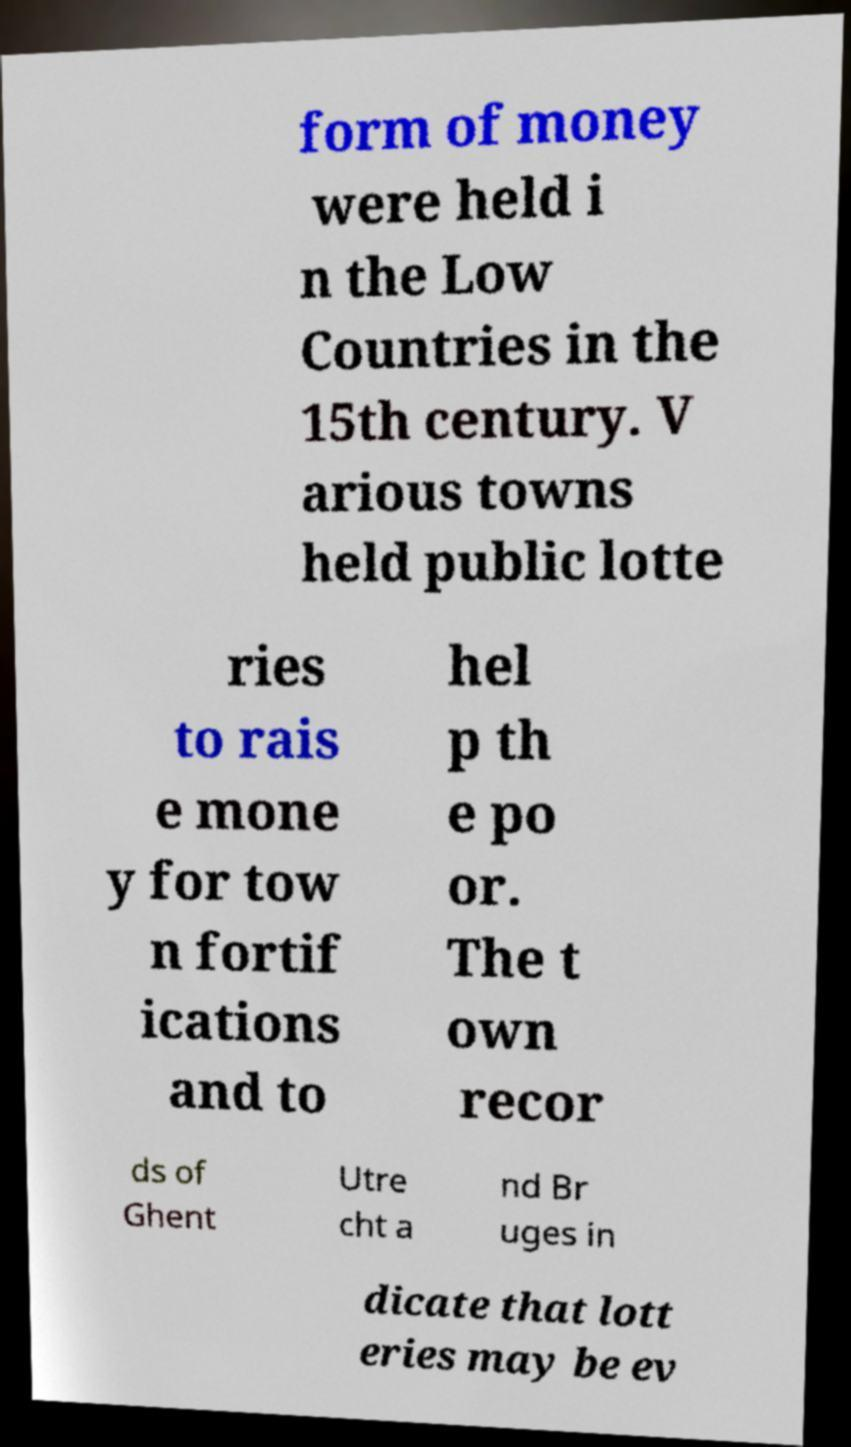I need the written content from this picture converted into text. Can you do that? form of money were held i n the Low Countries in the 15th century. V arious towns held public lotte ries to rais e mone y for tow n fortif ications and to hel p th e po or. The t own recor ds of Ghent Utre cht a nd Br uges in dicate that lott eries may be ev 